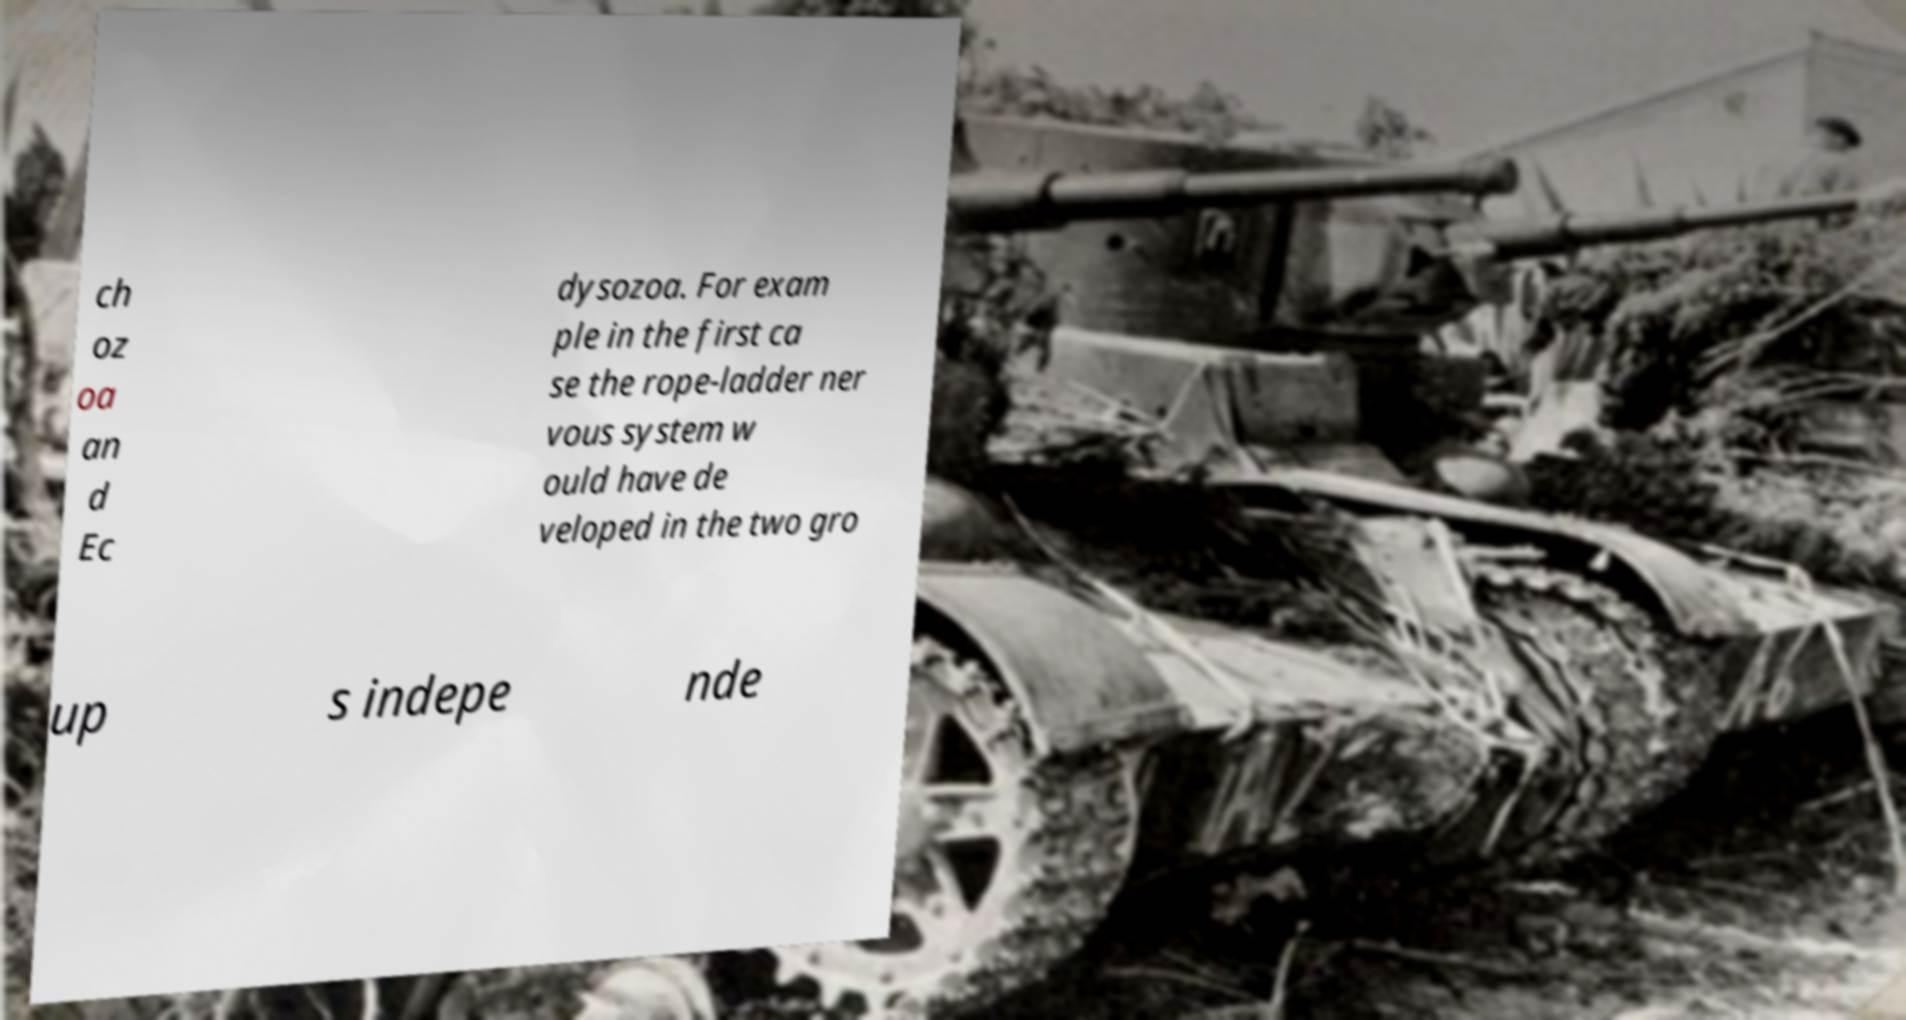There's text embedded in this image that I need extracted. Can you transcribe it verbatim? ch oz oa an d Ec dysozoa. For exam ple in the first ca se the rope-ladder ner vous system w ould have de veloped in the two gro up s indepe nde 